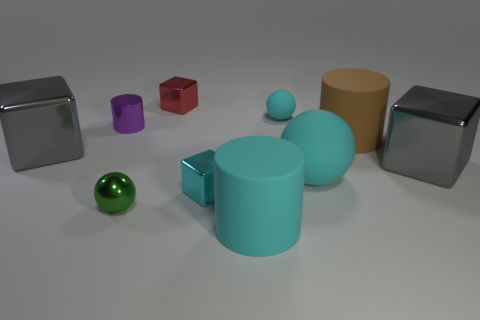Is the tiny rubber sphere the same color as the large ball?
Make the answer very short. Yes. What is the shape of the large cyan thing behind the rubber cylinder that is in front of the small metal ball?
Provide a succinct answer. Sphere. How many gray blocks are behind the tiny object that is to the right of the small cyan metal cube?
Your response must be concise. 0. What material is the big thing that is both left of the brown cylinder and on the right side of the tiny cyan matte sphere?
Offer a terse response. Rubber. There is a green shiny thing that is the same size as the purple cylinder; what shape is it?
Make the answer very short. Sphere. The metal ball left of the gray metallic block in front of the gray shiny object that is on the left side of the green object is what color?
Your response must be concise. Green. How many things are either small things right of the small cyan metallic block or big gray metallic cubes?
Ensure brevity in your answer.  3. There is a red block that is the same size as the purple cylinder; what is its material?
Make the answer very short. Metal. There is a large gray object behind the gray object in front of the thing left of the purple metal object; what is its material?
Keep it short and to the point. Metal. The shiny cylinder has what color?
Ensure brevity in your answer.  Purple. 